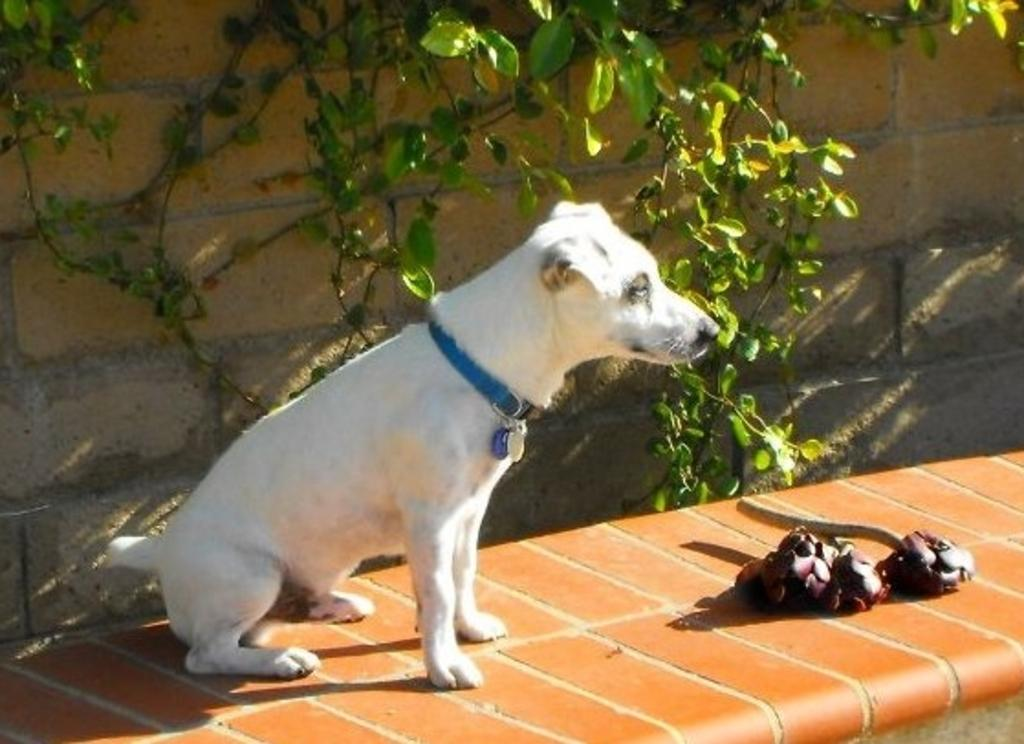What is the main structure visible in the image? There is a wall in the image. What type of living organisms can be seen in the image? There are plants in the image. What animal is present in the image? There is a white-colored dog sitting in the image. Who is the creator of the joke that is being told by the dog in the image? There is no joke being told by the dog in the image, as it is simply sitting. 